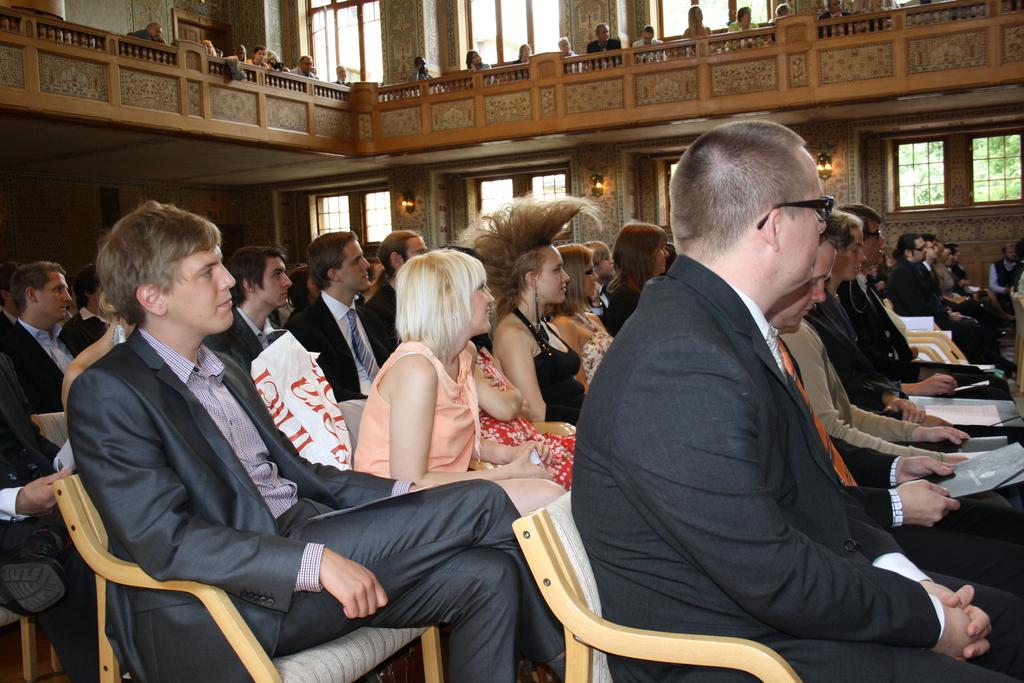What is the main subject of the image? The main subject of the image is a group of people. What are the people in the image doing? The people are sitting in chairs. What are the men wearing in the image? The men are wearing suits. Can you describe the seating arrangement in the image? There are people sitting in the top, possibly a higher level or elevated area. What type of industry is being discussed in the image? There is no indication of an industry being discussed in the image; it primarily features a group of people sitting in chairs. Can you tell me how many notebooks are visible in the image? There are no notebooks present in the image. 